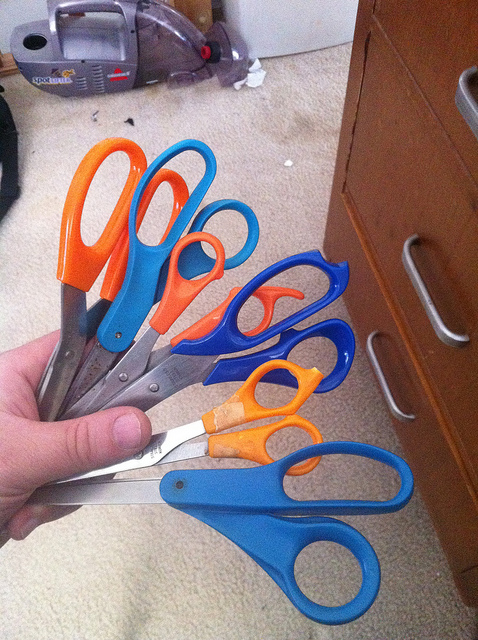What color is the smallest pair of scissors? The smallest pair of scissors in the image is orange. They seem to be designed for precision work or perhaps for a child's use, given their smaller size compared to the others, which are blue and are likely used for general cutting tasks. 